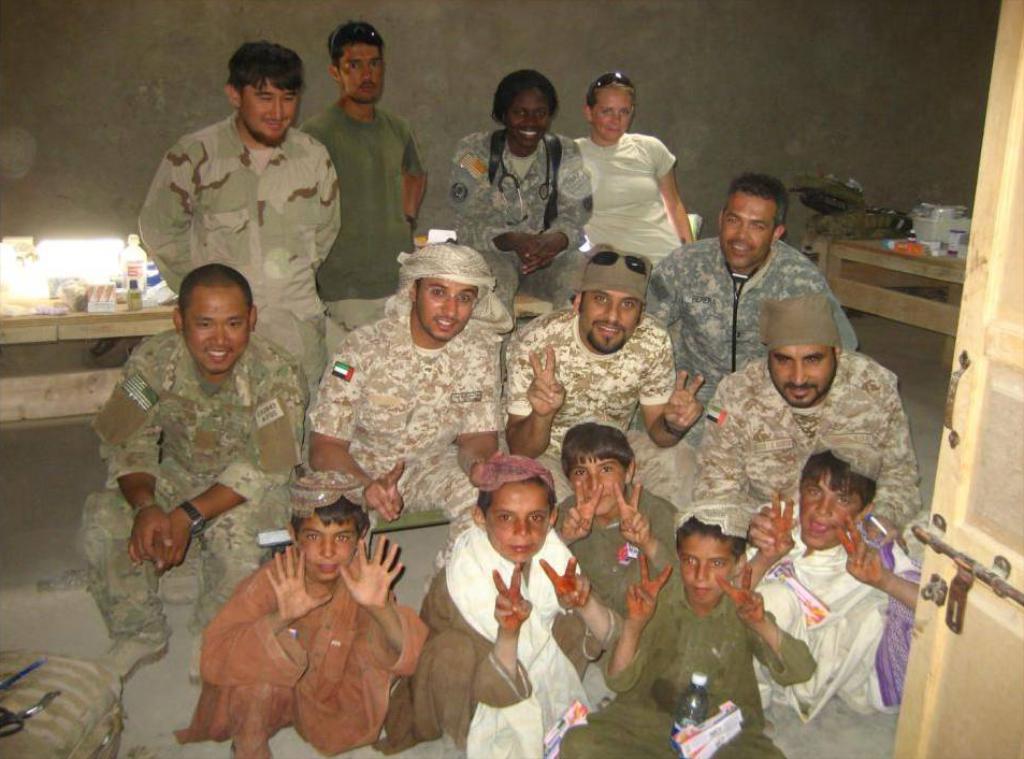Please provide a concise description of this image. In the center of the picture there are soldiers, people and kids. On the right there are table, kitchen utensils and door. On the left there are table, bag, bottles and other objects. In the background it is well. 